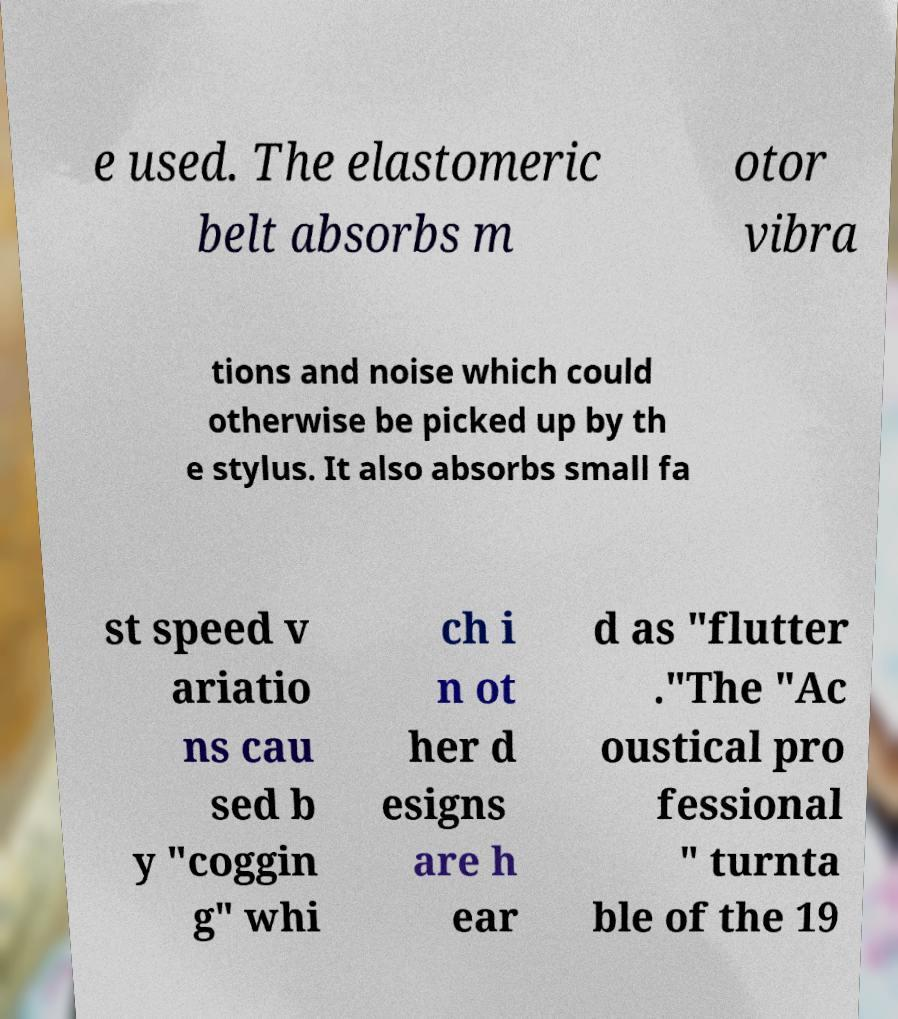For documentation purposes, I need the text within this image transcribed. Could you provide that? e used. The elastomeric belt absorbs m otor vibra tions and noise which could otherwise be picked up by th e stylus. It also absorbs small fa st speed v ariatio ns cau sed b y "coggin g" whi ch i n ot her d esigns are h ear d as "flutter ."The "Ac oustical pro fessional " turnta ble of the 19 